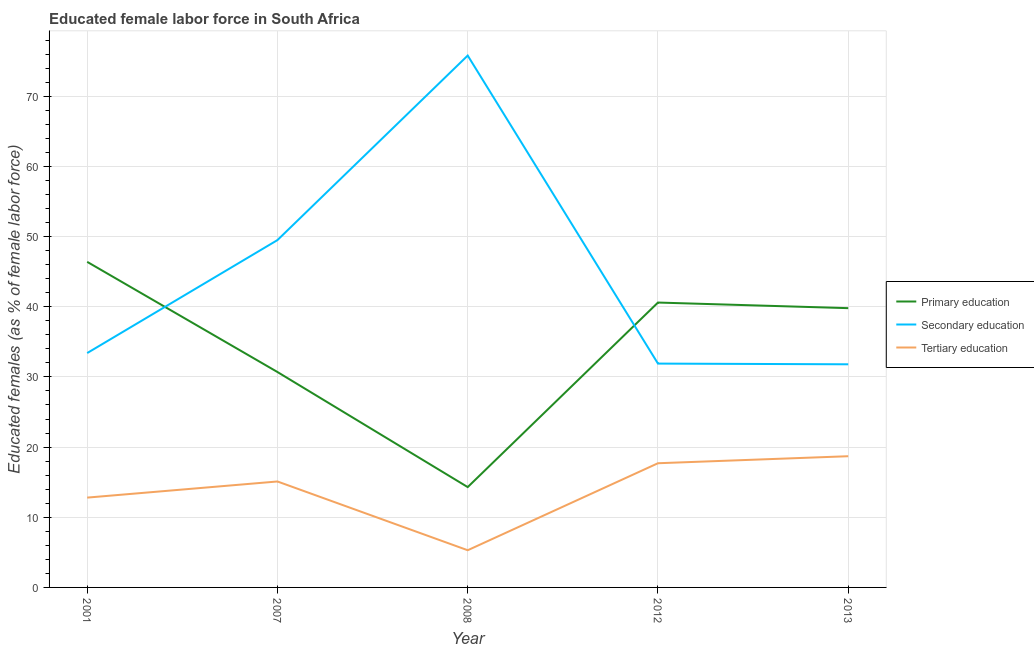Is the number of lines equal to the number of legend labels?
Provide a short and direct response. Yes. What is the percentage of female labor force who received tertiary education in 2013?
Ensure brevity in your answer.  18.7. Across all years, what is the maximum percentage of female labor force who received tertiary education?
Your answer should be very brief. 18.7. Across all years, what is the minimum percentage of female labor force who received primary education?
Provide a succinct answer. 14.3. In which year was the percentage of female labor force who received primary education maximum?
Offer a very short reply. 2001. What is the total percentage of female labor force who received secondary education in the graph?
Offer a terse response. 222.4. What is the difference between the percentage of female labor force who received tertiary education in 2008 and that in 2012?
Your answer should be compact. -12.4. What is the difference between the percentage of female labor force who received tertiary education in 2013 and the percentage of female labor force who received secondary education in 2012?
Offer a very short reply. -13.2. What is the average percentage of female labor force who received secondary education per year?
Your answer should be very brief. 44.48. In the year 2001, what is the difference between the percentage of female labor force who received primary education and percentage of female labor force who received tertiary education?
Offer a terse response. 33.6. What is the ratio of the percentage of female labor force who received primary education in 2001 to that in 2012?
Ensure brevity in your answer.  1.14. Is the percentage of female labor force who received primary education in 2001 less than that in 2013?
Your answer should be compact. No. What is the difference between the highest and the lowest percentage of female labor force who received secondary education?
Provide a short and direct response. 44. In how many years, is the percentage of female labor force who received secondary education greater than the average percentage of female labor force who received secondary education taken over all years?
Give a very brief answer. 2. Is it the case that in every year, the sum of the percentage of female labor force who received primary education and percentage of female labor force who received secondary education is greater than the percentage of female labor force who received tertiary education?
Your answer should be very brief. Yes. Does the percentage of female labor force who received secondary education monotonically increase over the years?
Your response must be concise. No. Is the percentage of female labor force who received secondary education strictly greater than the percentage of female labor force who received primary education over the years?
Ensure brevity in your answer.  No. How many lines are there?
Offer a very short reply. 3. Does the graph contain grids?
Make the answer very short. Yes. How are the legend labels stacked?
Offer a terse response. Vertical. What is the title of the graph?
Offer a very short reply. Educated female labor force in South Africa. Does "Domestic economy" appear as one of the legend labels in the graph?
Provide a short and direct response. No. What is the label or title of the X-axis?
Your response must be concise. Year. What is the label or title of the Y-axis?
Provide a succinct answer. Educated females (as % of female labor force). What is the Educated females (as % of female labor force) of Primary education in 2001?
Your answer should be compact. 46.4. What is the Educated females (as % of female labor force) of Secondary education in 2001?
Offer a terse response. 33.4. What is the Educated females (as % of female labor force) in Tertiary education in 2001?
Offer a terse response. 12.8. What is the Educated females (as % of female labor force) in Primary education in 2007?
Your answer should be compact. 30.7. What is the Educated females (as % of female labor force) in Secondary education in 2007?
Provide a succinct answer. 49.5. What is the Educated females (as % of female labor force) in Tertiary education in 2007?
Ensure brevity in your answer.  15.1. What is the Educated females (as % of female labor force) in Primary education in 2008?
Your answer should be compact. 14.3. What is the Educated females (as % of female labor force) of Secondary education in 2008?
Offer a terse response. 75.8. What is the Educated females (as % of female labor force) in Tertiary education in 2008?
Make the answer very short. 5.3. What is the Educated females (as % of female labor force) in Primary education in 2012?
Make the answer very short. 40.6. What is the Educated females (as % of female labor force) in Secondary education in 2012?
Provide a succinct answer. 31.9. What is the Educated females (as % of female labor force) in Tertiary education in 2012?
Make the answer very short. 17.7. What is the Educated females (as % of female labor force) in Primary education in 2013?
Provide a succinct answer. 39.8. What is the Educated females (as % of female labor force) of Secondary education in 2013?
Ensure brevity in your answer.  31.8. What is the Educated females (as % of female labor force) of Tertiary education in 2013?
Offer a terse response. 18.7. Across all years, what is the maximum Educated females (as % of female labor force) of Primary education?
Your response must be concise. 46.4. Across all years, what is the maximum Educated females (as % of female labor force) of Secondary education?
Provide a succinct answer. 75.8. Across all years, what is the maximum Educated females (as % of female labor force) of Tertiary education?
Your response must be concise. 18.7. Across all years, what is the minimum Educated females (as % of female labor force) of Primary education?
Your answer should be very brief. 14.3. Across all years, what is the minimum Educated females (as % of female labor force) in Secondary education?
Offer a terse response. 31.8. Across all years, what is the minimum Educated females (as % of female labor force) of Tertiary education?
Your answer should be very brief. 5.3. What is the total Educated females (as % of female labor force) of Primary education in the graph?
Your answer should be compact. 171.8. What is the total Educated females (as % of female labor force) of Secondary education in the graph?
Your response must be concise. 222.4. What is the total Educated females (as % of female labor force) in Tertiary education in the graph?
Keep it short and to the point. 69.6. What is the difference between the Educated females (as % of female labor force) in Primary education in 2001 and that in 2007?
Your response must be concise. 15.7. What is the difference between the Educated females (as % of female labor force) of Secondary education in 2001 and that in 2007?
Ensure brevity in your answer.  -16.1. What is the difference between the Educated females (as % of female labor force) of Tertiary education in 2001 and that in 2007?
Provide a short and direct response. -2.3. What is the difference between the Educated females (as % of female labor force) of Primary education in 2001 and that in 2008?
Make the answer very short. 32.1. What is the difference between the Educated females (as % of female labor force) of Secondary education in 2001 and that in 2008?
Provide a succinct answer. -42.4. What is the difference between the Educated females (as % of female labor force) of Tertiary education in 2001 and that in 2012?
Offer a terse response. -4.9. What is the difference between the Educated females (as % of female labor force) of Secondary education in 2001 and that in 2013?
Provide a succinct answer. 1.6. What is the difference between the Educated females (as % of female labor force) of Tertiary education in 2001 and that in 2013?
Give a very brief answer. -5.9. What is the difference between the Educated females (as % of female labor force) of Primary education in 2007 and that in 2008?
Give a very brief answer. 16.4. What is the difference between the Educated females (as % of female labor force) in Secondary education in 2007 and that in 2008?
Provide a succinct answer. -26.3. What is the difference between the Educated females (as % of female labor force) of Tertiary education in 2007 and that in 2008?
Make the answer very short. 9.8. What is the difference between the Educated females (as % of female labor force) in Primary education in 2007 and that in 2012?
Provide a short and direct response. -9.9. What is the difference between the Educated females (as % of female labor force) of Secondary education in 2007 and that in 2012?
Offer a very short reply. 17.6. What is the difference between the Educated females (as % of female labor force) in Tertiary education in 2007 and that in 2012?
Make the answer very short. -2.6. What is the difference between the Educated females (as % of female labor force) of Primary education in 2008 and that in 2012?
Your response must be concise. -26.3. What is the difference between the Educated females (as % of female labor force) in Secondary education in 2008 and that in 2012?
Offer a very short reply. 43.9. What is the difference between the Educated females (as % of female labor force) of Primary education in 2008 and that in 2013?
Provide a succinct answer. -25.5. What is the difference between the Educated females (as % of female labor force) of Secondary education in 2008 and that in 2013?
Your response must be concise. 44. What is the difference between the Educated females (as % of female labor force) of Tertiary education in 2008 and that in 2013?
Offer a terse response. -13.4. What is the difference between the Educated females (as % of female labor force) in Secondary education in 2012 and that in 2013?
Offer a very short reply. 0.1. What is the difference between the Educated females (as % of female labor force) in Primary education in 2001 and the Educated females (as % of female labor force) in Tertiary education in 2007?
Your response must be concise. 31.3. What is the difference between the Educated females (as % of female labor force) in Secondary education in 2001 and the Educated females (as % of female labor force) in Tertiary education in 2007?
Ensure brevity in your answer.  18.3. What is the difference between the Educated females (as % of female labor force) of Primary education in 2001 and the Educated females (as % of female labor force) of Secondary education in 2008?
Ensure brevity in your answer.  -29.4. What is the difference between the Educated females (as % of female labor force) in Primary education in 2001 and the Educated females (as % of female labor force) in Tertiary education in 2008?
Ensure brevity in your answer.  41.1. What is the difference between the Educated females (as % of female labor force) in Secondary education in 2001 and the Educated females (as % of female labor force) in Tertiary education in 2008?
Your answer should be compact. 28.1. What is the difference between the Educated females (as % of female labor force) of Primary education in 2001 and the Educated females (as % of female labor force) of Secondary education in 2012?
Offer a very short reply. 14.5. What is the difference between the Educated females (as % of female labor force) in Primary education in 2001 and the Educated females (as % of female labor force) in Tertiary education in 2012?
Provide a short and direct response. 28.7. What is the difference between the Educated females (as % of female labor force) of Secondary education in 2001 and the Educated females (as % of female labor force) of Tertiary education in 2012?
Give a very brief answer. 15.7. What is the difference between the Educated females (as % of female labor force) in Primary education in 2001 and the Educated females (as % of female labor force) in Secondary education in 2013?
Ensure brevity in your answer.  14.6. What is the difference between the Educated females (as % of female labor force) in Primary education in 2001 and the Educated females (as % of female labor force) in Tertiary education in 2013?
Make the answer very short. 27.7. What is the difference between the Educated females (as % of female labor force) of Primary education in 2007 and the Educated females (as % of female labor force) of Secondary education in 2008?
Offer a very short reply. -45.1. What is the difference between the Educated females (as % of female labor force) of Primary education in 2007 and the Educated females (as % of female labor force) of Tertiary education in 2008?
Provide a succinct answer. 25.4. What is the difference between the Educated females (as % of female labor force) in Secondary education in 2007 and the Educated females (as % of female labor force) in Tertiary education in 2008?
Provide a short and direct response. 44.2. What is the difference between the Educated females (as % of female labor force) of Primary education in 2007 and the Educated females (as % of female labor force) of Secondary education in 2012?
Your answer should be compact. -1.2. What is the difference between the Educated females (as % of female labor force) in Secondary education in 2007 and the Educated females (as % of female labor force) in Tertiary education in 2012?
Ensure brevity in your answer.  31.8. What is the difference between the Educated females (as % of female labor force) in Primary education in 2007 and the Educated females (as % of female labor force) in Secondary education in 2013?
Give a very brief answer. -1.1. What is the difference between the Educated females (as % of female labor force) in Secondary education in 2007 and the Educated females (as % of female labor force) in Tertiary education in 2013?
Provide a short and direct response. 30.8. What is the difference between the Educated females (as % of female labor force) of Primary education in 2008 and the Educated females (as % of female labor force) of Secondary education in 2012?
Give a very brief answer. -17.6. What is the difference between the Educated females (as % of female labor force) of Primary education in 2008 and the Educated females (as % of female labor force) of Tertiary education in 2012?
Make the answer very short. -3.4. What is the difference between the Educated females (as % of female labor force) of Secondary education in 2008 and the Educated females (as % of female labor force) of Tertiary education in 2012?
Offer a terse response. 58.1. What is the difference between the Educated females (as % of female labor force) of Primary education in 2008 and the Educated females (as % of female labor force) of Secondary education in 2013?
Your answer should be compact. -17.5. What is the difference between the Educated females (as % of female labor force) of Primary education in 2008 and the Educated females (as % of female labor force) of Tertiary education in 2013?
Make the answer very short. -4.4. What is the difference between the Educated females (as % of female labor force) in Secondary education in 2008 and the Educated females (as % of female labor force) in Tertiary education in 2013?
Provide a succinct answer. 57.1. What is the difference between the Educated females (as % of female labor force) in Primary education in 2012 and the Educated females (as % of female labor force) in Secondary education in 2013?
Keep it short and to the point. 8.8. What is the difference between the Educated females (as % of female labor force) in Primary education in 2012 and the Educated females (as % of female labor force) in Tertiary education in 2013?
Provide a short and direct response. 21.9. What is the difference between the Educated females (as % of female labor force) in Secondary education in 2012 and the Educated females (as % of female labor force) in Tertiary education in 2013?
Ensure brevity in your answer.  13.2. What is the average Educated females (as % of female labor force) of Primary education per year?
Make the answer very short. 34.36. What is the average Educated females (as % of female labor force) in Secondary education per year?
Keep it short and to the point. 44.48. What is the average Educated females (as % of female labor force) of Tertiary education per year?
Keep it short and to the point. 13.92. In the year 2001, what is the difference between the Educated females (as % of female labor force) of Primary education and Educated females (as % of female labor force) of Secondary education?
Your response must be concise. 13. In the year 2001, what is the difference between the Educated females (as % of female labor force) in Primary education and Educated females (as % of female labor force) in Tertiary education?
Your answer should be compact. 33.6. In the year 2001, what is the difference between the Educated females (as % of female labor force) of Secondary education and Educated females (as % of female labor force) of Tertiary education?
Keep it short and to the point. 20.6. In the year 2007, what is the difference between the Educated females (as % of female labor force) in Primary education and Educated females (as % of female labor force) in Secondary education?
Offer a terse response. -18.8. In the year 2007, what is the difference between the Educated females (as % of female labor force) in Secondary education and Educated females (as % of female labor force) in Tertiary education?
Your answer should be very brief. 34.4. In the year 2008, what is the difference between the Educated females (as % of female labor force) of Primary education and Educated females (as % of female labor force) of Secondary education?
Offer a terse response. -61.5. In the year 2008, what is the difference between the Educated females (as % of female labor force) in Secondary education and Educated females (as % of female labor force) in Tertiary education?
Make the answer very short. 70.5. In the year 2012, what is the difference between the Educated females (as % of female labor force) of Primary education and Educated females (as % of female labor force) of Secondary education?
Keep it short and to the point. 8.7. In the year 2012, what is the difference between the Educated females (as % of female labor force) in Primary education and Educated females (as % of female labor force) in Tertiary education?
Provide a short and direct response. 22.9. In the year 2012, what is the difference between the Educated females (as % of female labor force) of Secondary education and Educated females (as % of female labor force) of Tertiary education?
Your response must be concise. 14.2. In the year 2013, what is the difference between the Educated females (as % of female labor force) in Primary education and Educated females (as % of female labor force) in Secondary education?
Offer a very short reply. 8. In the year 2013, what is the difference between the Educated females (as % of female labor force) of Primary education and Educated females (as % of female labor force) of Tertiary education?
Your answer should be compact. 21.1. What is the ratio of the Educated females (as % of female labor force) of Primary education in 2001 to that in 2007?
Ensure brevity in your answer.  1.51. What is the ratio of the Educated females (as % of female labor force) in Secondary education in 2001 to that in 2007?
Provide a short and direct response. 0.67. What is the ratio of the Educated females (as % of female labor force) of Tertiary education in 2001 to that in 2007?
Give a very brief answer. 0.85. What is the ratio of the Educated females (as % of female labor force) of Primary education in 2001 to that in 2008?
Provide a succinct answer. 3.24. What is the ratio of the Educated females (as % of female labor force) in Secondary education in 2001 to that in 2008?
Provide a short and direct response. 0.44. What is the ratio of the Educated females (as % of female labor force) of Tertiary education in 2001 to that in 2008?
Make the answer very short. 2.42. What is the ratio of the Educated females (as % of female labor force) of Primary education in 2001 to that in 2012?
Offer a very short reply. 1.14. What is the ratio of the Educated females (as % of female labor force) of Secondary education in 2001 to that in 2012?
Make the answer very short. 1.05. What is the ratio of the Educated females (as % of female labor force) in Tertiary education in 2001 to that in 2012?
Provide a succinct answer. 0.72. What is the ratio of the Educated females (as % of female labor force) of Primary education in 2001 to that in 2013?
Give a very brief answer. 1.17. What is the ratio of the Educated females (as % of female labor force) of Secondary education in 2001 to that in 2013?
Make the answer very short. 1.05. What is the ratio of the Educated females (as % of female labor force) in Tertiary education in 2001 to that in 2013?
Provide a short and direct response. 0.68. What is the ratio of the Educated females (as % of female labor force) of Primary education in 2007 to that in 2008?
Ensure brevity in your answer.  2.15. What is the ratio of the Educated females (as % of female labor force) of Secondary education in 2007 to that in 2008?
Your answer should be very brief. 0.65. What is the ratio of the Educated females (as % of female labor force) of Tertiary education in 2007 to that in 2008?
Make the answer very short. 2.85. What is the ratio of the Educated females (as % of female labor force) in Primary education in 2007 to that in 2012?
Your response must be concise. 0.76. What is the ratio of the Educated females (as % of female labor force) in Secondary education in 2007 to that in 2012?
Your response must be concise. 1.55. What is the ratio of the Educated females (as % of female labor force) in Tertiary education in 2007 to that in 2012?
Give a very brief answer. 0.85. What is the ratio of the Educated females (as % of female labor force) in Primary education in 2007 to that in 2013?
Provide a succinct answer. 0.77. What is the ratio of the Educated females (as % of female labor force) in Secondary education in 2007 to that in 2013?
Provide a succinct answer. 1.56. What is the ratio of the Educated females (as % of female labor force) of Tertiary education in 2007 to that in 2013?
Your answer should be very brief. 0.81. What is the ratio of the Educated females (as % of female labor force) of Primary education in 2008 to that in 2012?
Your answer should be very brief. 0.35. What is the ratio of the Educated females (as % of female labor force) of Secondary education in 2008 to that in 2012?
Provide a short and direct response. 2.38. What is the ratio of the Educated females (as % of female labor force) of Tertiary education in 2008 to that in 2012?
Offer a very short reply. 0.3. What is the ratio of the Educated females (as % of female labor force) of Primary education in 2008 to that in 2013?
Your response must be concise. 0.36. What is the ratio of the Educated females (as % of female labor force) in Secondary education in 2008 to that in 2013?
Your answer should be very brief. 2.38. What is the ratio of the Educated females (as % of female labor force) in Tertiary education in 2008 to that in 2013?
Your response must be concise. 0.28. What is the ratio of the Educated females (as % of female labor force) of Primary education in 2012 to that in 2013?
Make the answer very short. 1.02. What is the ratio of the Educated females (as % of female labor force) of Tertiary education in 2012 to that in 2013?
Provide a short and direct response. 0.95. What is the difference between the highest and the second highest Educated females (as % of female labor force) in Secondary education?
Provide a succinct answer. 26.3. What is the difference between the highest and the second highest Educated females (as % of female labor force) in Tertiary education?
Offer a very short reply. 1. What is the difference between the highest and the lowest Educated females (as % of female labor force) of Primary education?
Provide a short and direct response. 32.1. What is the difference between the highest and the lowest Educated females (as % of female labor force) in Tertiary education?
Keep it short and to the point. 13.4. 